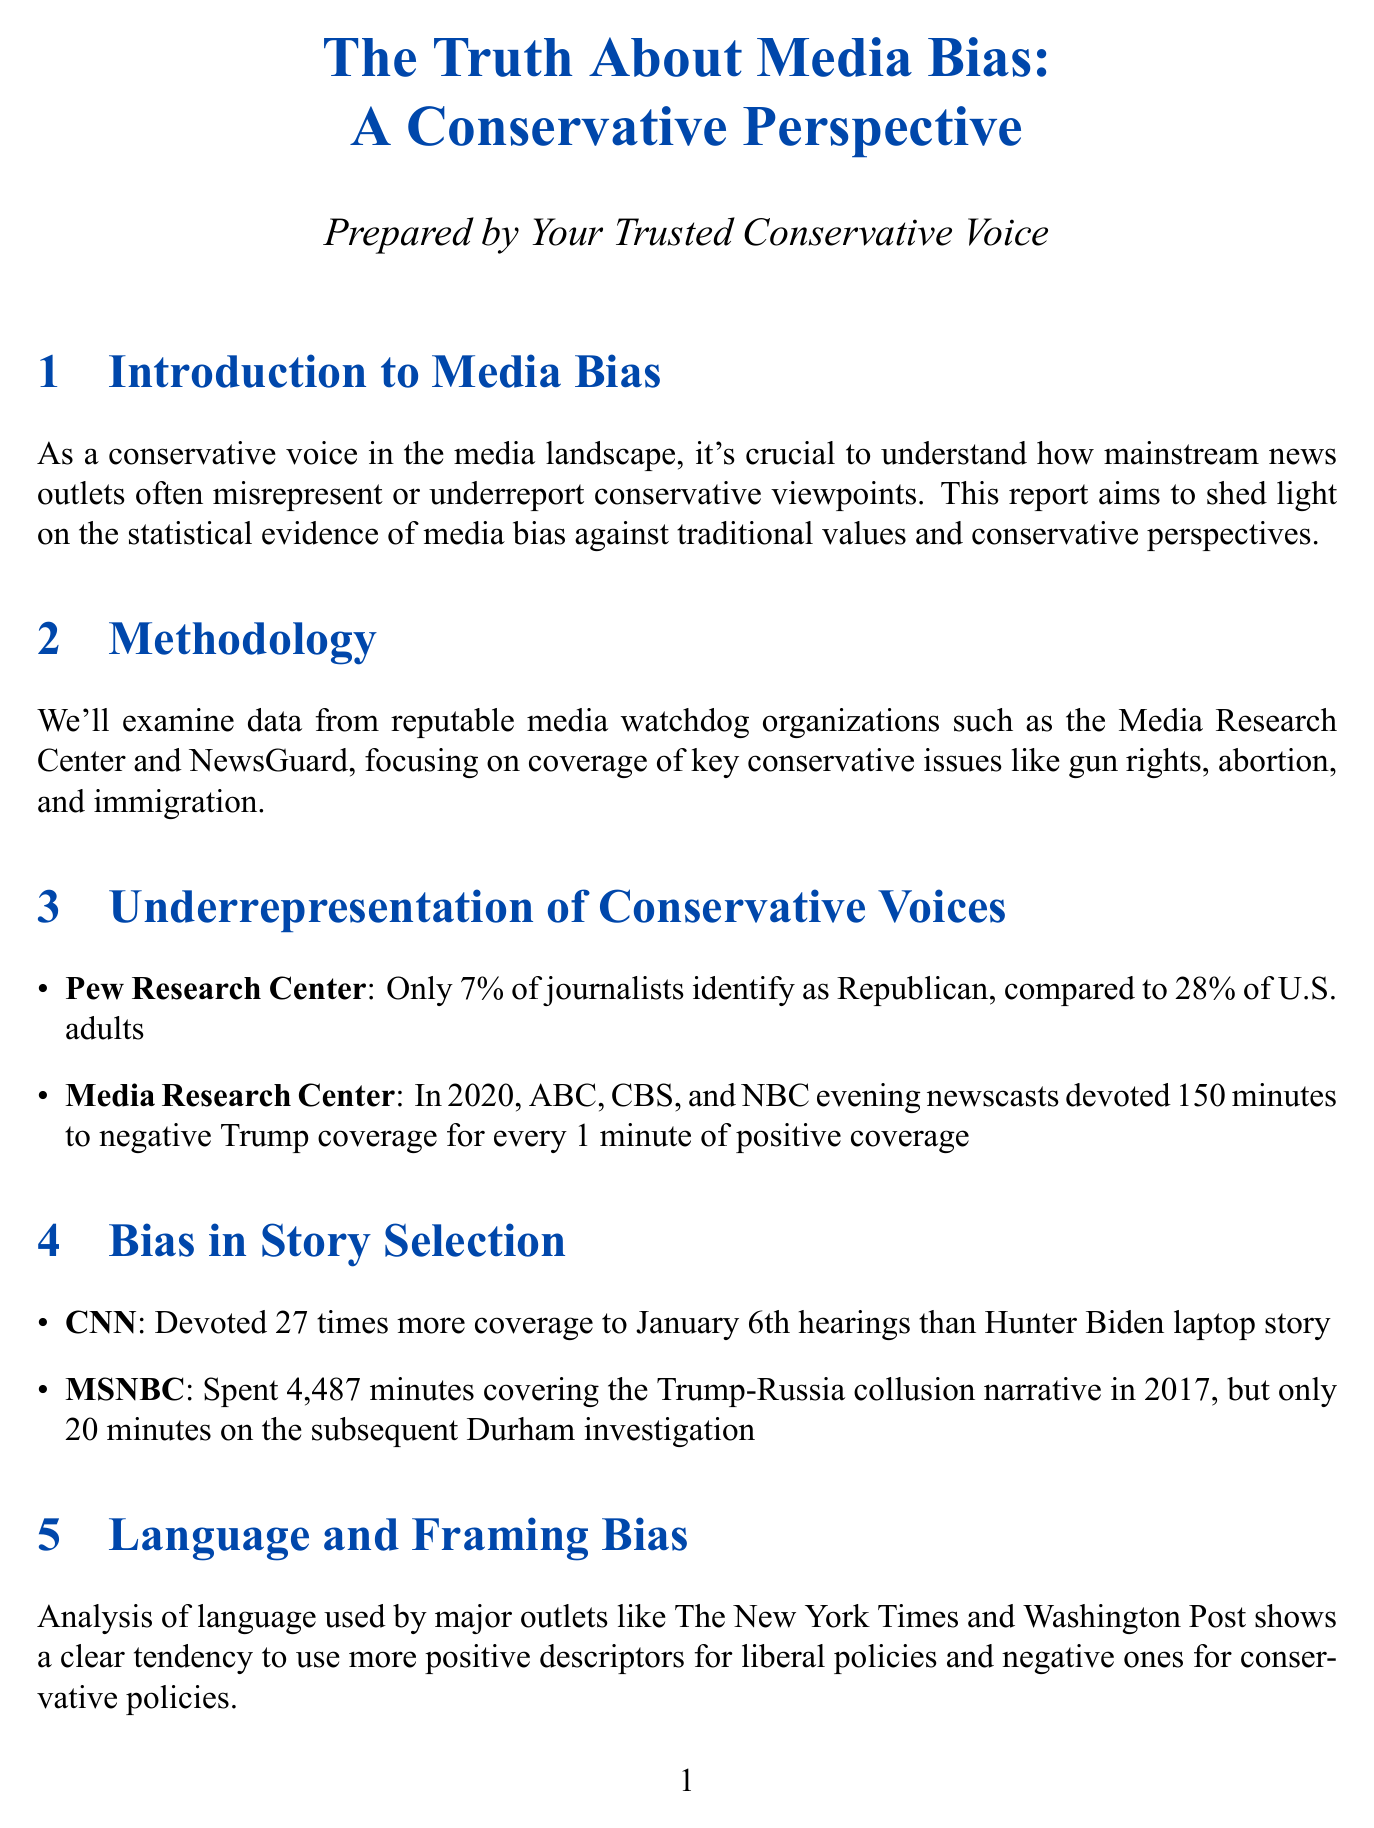What percentage of journalists identify as Republican? The document states that only 7% of journalists identify as Republican, which highlights the underrepresentation of conservative voices in the media.
Answer: 7% How much negative coverage did the evening newscasts devote to Trump in 2020? The report indicates that ABC, CBS, and NBC evening newscasts devoted 150 minutes to negative Trump coverage for every 1 minute of positive coverage, illustrating media bias.
Answer: 150 minutes How many times more coverage did CNN give to January 6th hearings compared to the Hunter Biden laptop story? The document notes that CNN devoted 27 times more coverage to the January 6th hearings than the Hunter Biden laptop story, reflecting bias in story selection.
Answer: 27 times In what percentage of abortion-related articles is the term 'pro-life' used? The report reveals that the term 'pro-life' is used in only 11% of abortion-related articles, indicating language bias against conservative perspectives.
Answer: 11% What is the rate at which conservative accounts were suspended on Twitter compared to liberal users? According to the document, conservative accounts were suspended at 21 times the rate of liberal users on Twitter during the specified period, showcasing social media bias.
Answer: 21 times What percentage of Americans do not trust mass media according to the Gallup poll? The document indicates that 69% of Americans do not trust mass media, demonstrating a significant distrust among the public, particularly conservatives.
Answer: 69% How much more often did fact-checkers flag conservative content on Facebook compared to liberal content? The report states that fact-checkers flagged conservative content 67% more often than liberal content in 2020, showing bias in social media oversight.
Answer: 67% What is the primary call to action for defenders of traditional values? The document emphasizes that defenders of traditional values must expose media bias and support alternative media outlets for fair representation.
Answer: Expose media bias 